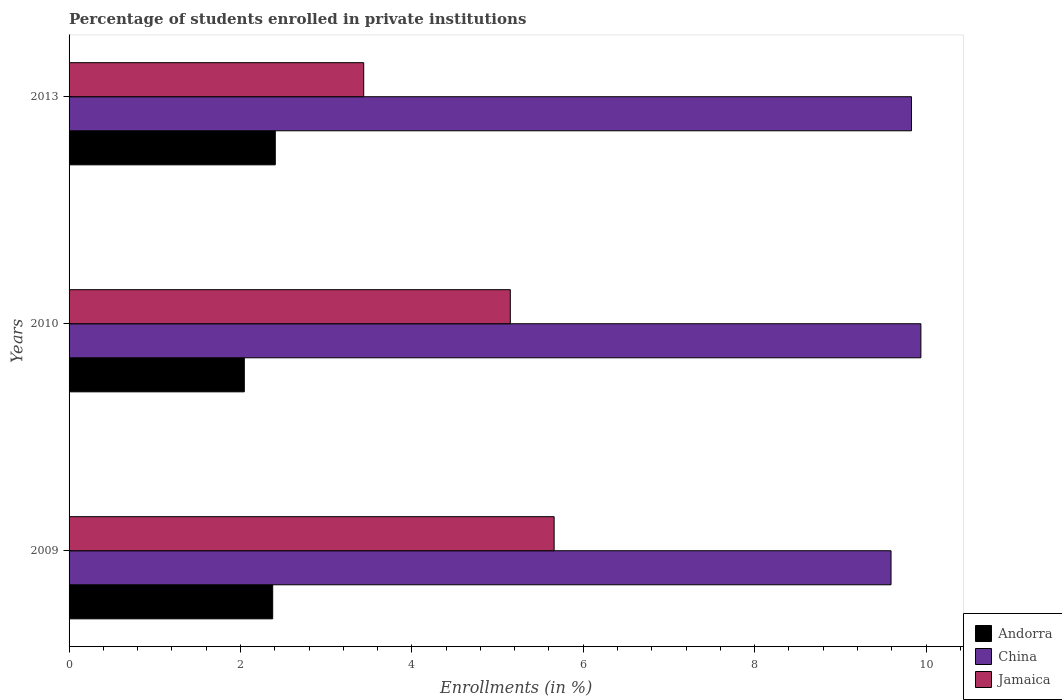How many groups of bars are there?
Make the answer very short. 3. Are the number of bars per tick equal to the number of legend labels?
Your answer should be compact. Yes. How many bars are there on the 2nd tick from the top?
Make the answer very short. 3. How many bars are there on the 3rd tick from the bottom?
Make the answer very short. 3. What is the percentage of trained teachers in Jamaica in 2013?
Offer a terse response. 3.44. Across all years, what is the maximum percentage of trained teachers in Jamaica?
Your answer should be very brief. 5.66. Across all years, what is the minimum percentage of trained teachers in Jamaica?
Provide a succinct answer. 3.44. In which year was the percentage of trained teachers in Andorra minimum?
Provide a short and direct response. 2010. What is the total percentage of trained teachers in Andorra in the graph?
Provide a short and direct response. 6.83. What is the difference between the percentage of trained teachers in Jamaica in 2010 and that in 2013?
Offer a very short reply. 1.71. What is the difference between the percentage of trained teachers in China in 2010 and the percentage of trained teachers in Andorra in 2009?
Your answer should be very brief. 7.56. What is the average percentage of trained teachers in China per year?
Provide a succinct answer. 9.79. In the year 2010, what is the difference between the percentage of trained teachers in China and percentage of trained teachers in Andorra?
Offer a very short reply. 7.9. What is the ratio of the percentage of trained teachers in Andorra in 2010 to that in 2013?
Provide a succinct answer. 0.85. What is the difference between the highest and the second highest percentage of trained teachers in Jamaica?
Offer a very short reply. 0.51. What is the difference between the highest and the lowest percentage of trained teachers in China?
Ensure brevity in your answer.  0.35. What does the 3rd bar from the top in 2010 represents?
Offer a very short reply. Andorra. What does the 2nd bar from the bottom in 2013 represents?
Keep it short and to the point. China. Are all the bars in the graph horizontal?
Your answer should be compact. Yes. What is the difference between two consecutive major ticks on the X-axis?
Offer a terse response. 2. Does the graph contain any zero values?
Offer a very short reply. No. How many legend labels are there?
Offer a terse response. 3. What is the title of the graph?
Your answer should be very brief. Percentage of students enrolled in private institutions. Does "Israel" appear as one of the legend labels in the graph?
Offer a terse response. No. What is the label or title of the X-axis?
Your response must be concise. Enrollments (in %). What is the label or title of the Y-axis?
Offer a very short reply. Years. What is the Enrollments (in %) of Andorra in 2009?
Offer a very short reply. 2.38. What is the Enrollments (in %) in China in 2009?
Your response must be concise. 9.59. What is the Enrollments (in %) in Jamaica in 2009?
Keep it short and to the point. 5.66. What is the Enrollments (in %) of Andorra in 2010?
Give a very brief answer. 2.04. What is the Enrollments (in %) of China in 2010?
Your answer should be very brief. 9.94. What is the Enrollments (in %) in Jamaica in 2010?
Offer a very short reply. 5.15. What is the Enrollments (in %) of Andorra in 2013?
Give a very brief answer. 2.41. What is the Enrollments (in %) in China in 2013?
Your answer should be very brief. 9.83. What is the Enrollments (in %) of Jamaica in 2013?
Provide a short and direct response. 3.44. Across all years, what is the maximum Enrollments (in %) of Andorra?
Give a very brief answer. 2.41. Across all years, what is the maximum Enrollments (in %) of China?
Offer a terse response. 9.94. Across all years, what is the maximum Enrollments (in %) in Jamaica?
Keep it short and to the point. 5.66. Across all years, what is the minimum Enrollments (in %) in Andorra?
Provide a succinct answer. 2.04. Across all years, what is the minimum Enrollments (in %) in China?
Give a very brief answer. 9.59. Across all years, what is the minimum Enrollments (in %) in Jamaica?
Make the answer very short. 3.44. What is the total Enrollments (in %) of Andorra in the graph?
Give a very brief answer. 6.83. What is the total Enrollments (in %) of China in the graph?
Give a very brief answer. 29.36. What is the total Enrollments (in %) in Jamaica in the graph?
Give a very brief answer. 14.25. What is the difference between the Enrollments (in %) of Andorra in 2009 and that in 2010?
Provide a short and direct response. 0.33. What is the difference between the Enrollments (in %) of China in 2009 and that in 2010?
Your answer should be very brief. -0.35. What is the difference between the Enrollments (in %) in Jamaica in 2009 and that in 2010?
Keep it short and to the point. 0.51. What is the difference between the Enrollments (in %) in Andorra in 2009 and that in 2013?
Provide a short and direct response. -0.03. What is the difference between the Enrollments (in %) in China in 2009 and that in 2013?
Keep it short and to the point. -0.24. What is the difference between the Enrollments (in %) in Jamaica in 2009 and that in 2013?
Offer a terse response. 2.22. What is the difference between the Enrollments (in %) in Andorra in 2010 and that in 2013?
Your response must be concise. -0.36. What is the difference between the Enrollments (in %) in China in 2010 and that in 2013?
Offer a very short reply. 0.11. What is the difference between the Enrollments (in %) of Jamaica in 2010 and that in 2013?
Make the answer very short. 1.71. What is the difference between the Enrollments (in %) in Andorra in 2009 and the Enrollments (in %) in China in 2010?
Provide a succinct answer. -7.56. What is the difference between the Enrollments (in %) of Andorra in 2009 and the Enrollments (in %) of Jamaica in 2010?
Make the answer very short. -2.77. What is the difference between the Enrollments (in %) of China in 2009 and the Enrollments (in %) of Jamaica in 2010?
Offer a very short reply. 4.44. What is the difference between the Enrollments (in %) of Andorra in 2009 and the Enrollments (in %) of China in 2013?
Ensure brevity in your answer.  -7.45. What is the difference between the Enrollments (in %) in Andorra in 2009 and the Enrollments (in %) in Jamaica in 2013?
Ensure brevity in your answer.  -1.06. What is the difference between the Enrollments (in %) of China in 2009 and the Enrollments (in %) of Jamaica in 2013?
Offer a terse response. 6.15. What is the difference between the Enrollments (in %) in Andorra in 2010 and the Enrollments (in %) in China in 2013?
Give a very brief answer. -7.79. What is the difference between the Enrollments (in %) in Andorra in 2010 and the Enrollments (in %) in Jamaica in 2013?
Provide a succinct answer. -1.39. What is the difference between the Enrollments (in %) of China in 2010 and the Enrollments (in %) of Jamaica in 2013?
Provide a succinct answer. 6.5. What is the average Enrollments (in %) in Andorra per year?
Keep it short and to the point. 2.28. What is the average Enrollments (in %) of China per year?
Offer a very short reply. 9.79. What is the average Enrollments (in %) of Jamaica per year?
Your answer should be very brief. 4.75. In the year 2009, what is the difference between the Enrollments (in %) in Andorra and Enrollments (in %) in China?
Give a very brief answer. -7.22. In the year 2009, what is the difference between the Enrollments (in %) of Andorra and Enrollments (in %) of Jamaica?
Keep it short and to the point. -3.28. In the year 2009, what is the difference between the Enrollments (in %) in China and Enrollments (in %) in Jamaica?
Make the answer very short. 3.93. In the year 2010, what is the difference between the Enrollments (in %) in Andorra and Enrollments (in %) in China?
Your answer should be compact. -7.89. In the year 2010, what is the difference between the Enrollments (in %) of Andorra and Enrollments (in %) of Jamaica?
Your response must be concise. -3.1. In the year 2010, what is the difference between the Enrollments (in %) of China and Enrollments (in %) of Jamaica?
Offer a terse response. 4.79. In the year 2013, what is the difference between the Enrollments (in %) of Andorra and Enrollments (in %) of China?
Keep it short and to the point. -7.42. In the year 2013, what is the difference between the Enrollments (in %) of Andorra and Enrollments (in %) of Jamaica?
Your answer should be compact. -1.03. In the year 2013, what is the difference between the Enrollments (in %) in China and Enrollments (in %) in Jamaica?
Give a very brief answer. 6.39. What is the ratio of the Enrollments (in %) of Andorra in 2009 to that in 2010?
Offer a very short reply. 1.16. What is the ratio of the Enrollments (in %) in Jamaica in 2009 to that in 2010?
Your answer should be compact. 1.1. What is the ratio of the Enrollments (in %) in Andorra in 2009 to that in 2013?
Provide a succinct answer. 0.99. What is the ratio of the Enrollments (in %) in China in 2009 to that in 2013?
Offer a very short reply. 0.98. What is the ratio of the Enrollments (in %) of Jamaica in 2009 to that in 2013?
Offer a terse response. 1.65. What is the ratio of the Enrollments (in %) in Andorra in 2010 to that in 2013?
Your answer should be compact. 0.85. What is the ratio of the Enrollments (in %) of China in 2010 to that in 2013?
Provide a short and direct response. 1.01. What is the ratio of the Enrollments (in %) of Jamaica in 2010 to that in 2013?
Give a very brief answer. 1.5. What is the difference between the highest and the second highest Enrollments (in %) in Andorra?
Provide a short and direct response. 0.03. What is the difference between the highest and the second highest Enrollments (in %) in China?
Ensure brevity in your answer.  0.11. What is the difference between the highest and the second highest Enrollments (in %) in Jamaica?
Provide a short and direct response. 0.51. What is the difference between the highest and the lowest Enrollments (in %) in Andorra?
Offer a terse response. 0.36. What is the difference between the highest and the lowest Enrollments (in %) in China?
Your response must be concise. 0.35. What is the difference between the highest and the lowest Enrollments (in %) of Jamaica?
Your response must be concise. 2.22. 